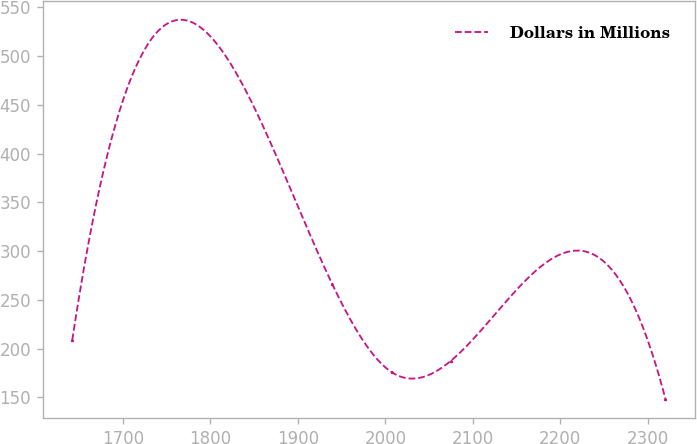<chart> <loc_0><loc_0><loc_500><loc_500><line_chart><ecel><fcel>Dollars in Millions<nl><fcel>1641.86<fcel>208.57<nl><fcel>1939.41<fcel>265.98<nl><fcel>2007.27<fcel>175.85<nl><fcel>2075.13<fcel>187.61<nl><fcel>2320.42<fcel>148.39<nl></chart> 